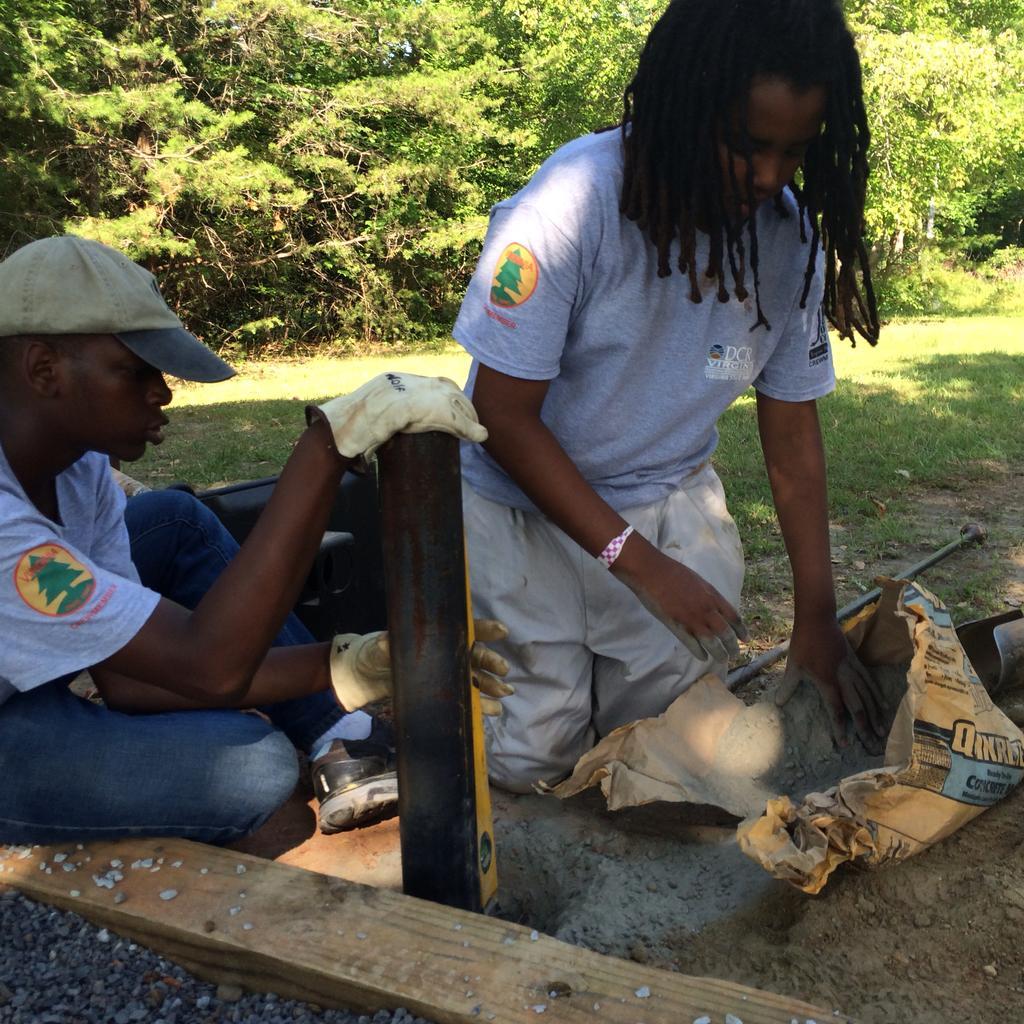How would you summarize this image in a sentence or two? In the image on the left side there is a boy with a cap on his head is sitting and holding an object in the hand. Beside him there is a person and in front of that person there is an object and also there is a rod on the ground. At the bottom of the image there is a wooden object and also there are small stones. In the background there are trees. 